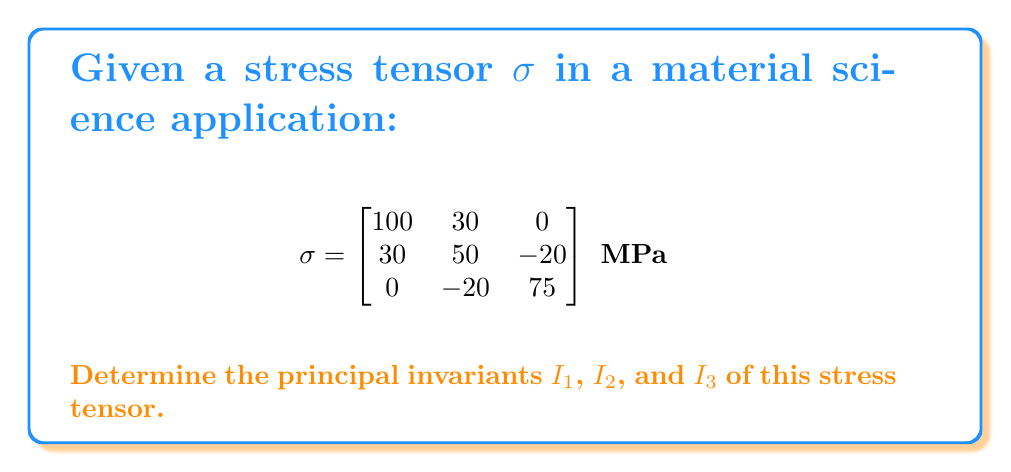Help me with this question. To determine the principal invariants of the stress tensor, we'll follow these steps:

1. Recall the formulas for the principal invariants:
   $I_1 = tr(\sigma)$
   $I_2 = \frac{1}{2}[(tr(\sigma))^2 - tr(\sigma^2)]$
   $I_3 = det(\sigma)$

2. Calculate $I_1$:
   $I_1 = tr(\sigma) = \sigma_{11} + \sigma_{22} + \sigma_{33}$
   $I_1 = 100 + 50 + 75 = 225$ MPa

3. Calculate $I_2$:
   First, we need $tr(\sigma^2)$:
   $\sigma^2 = \begin{bmatrix}
   100 & 30 & 0 \\
   30 & 50 & -20 \\
   0 & -20 & 75
   \end{bmatrix} \times \begin{bmatrix}
   100 & 30 & 0 \\
   30 & 50 & -20 \\
   0 & -20 & 75
   \end{bmatrix}$

   $\sigma^2 = \begin{bmatrix}
   10900 & 4500 & -600 \\
   4500 & 4900 & -2600 \\
   -600 & -2600 & 6125
   \end{bmatrix}$

   $tr(\sigma^2) = 10900 + 4900 + 6125 = 21925$ MPa²

   Now we can calculate $I_2$:
   $I_2 = \frac{1}{2}[(225)^2 - 21925] = 13418.75$ MPa²

4. Calculate $I_3$:
   $I_3 = det(\sigma) = 100(50 \times 75 - (-20)^2) - 30(30 \times 75 - 0 \times (-20)) + 0(30 \times (-20) - 0 \times 50)$
   $I_3 = 100(3750 - 400) - 30(2250) + 0$
   $I_3 = 335000 - 67500 = 267500$ MPa³
Answer: $I_1 = 225$ MPa, $I_2 = 13418.75$ MPa², $I_3 = 267500$ MPa³ 